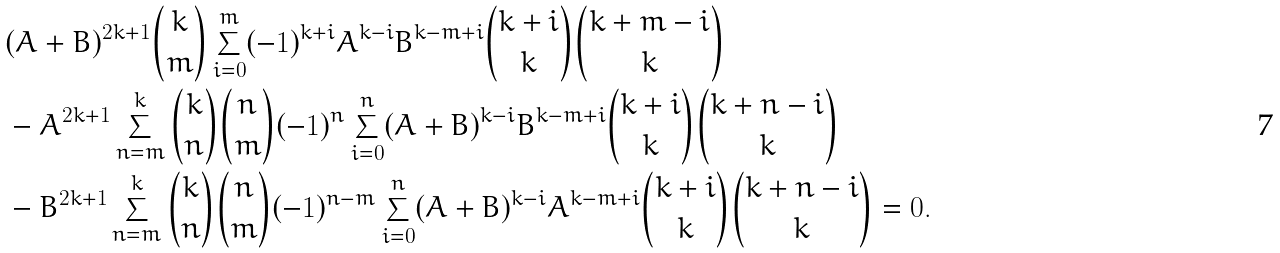<formula> <loc_0><loc_0><loc_500><loc_500>& ( A + B ) ^ { 2 k + 1 } \binom { k } { m } \sum _ { i = 0 } ^ { m } ( - 1 ) ^ { k + i } A ^ { k - i } B ^ { k - m + i } \binom { k + i } { k } \binom { k + m - i } { k } \\ & - A ^ { 2 k + 1 } \sum _ { n = m } ^ { k } \binom { k } { n } \binom { n } { m } ( - 1 ) ^ { n } \sum _ { i = 0 } ^ { n } ( A + B ) ^ { k - i } B ^ { k - m + i } \binom { k + i } { k } \binom { k + n - i } { k } \\ & - B ^ { 2 k + 1 } \sum _ { n = m } ^ { k } \binom { k } { n } \binom { n } { m } ( - 1 ) ^ { n - m } \sum _ { i = 0 } ^ { n } ( A + B ) ^ { k - i } A ^ { k - m + i } \binom { k + i } { k } \binom { k + n - i } { k } = 0 .</formula> 